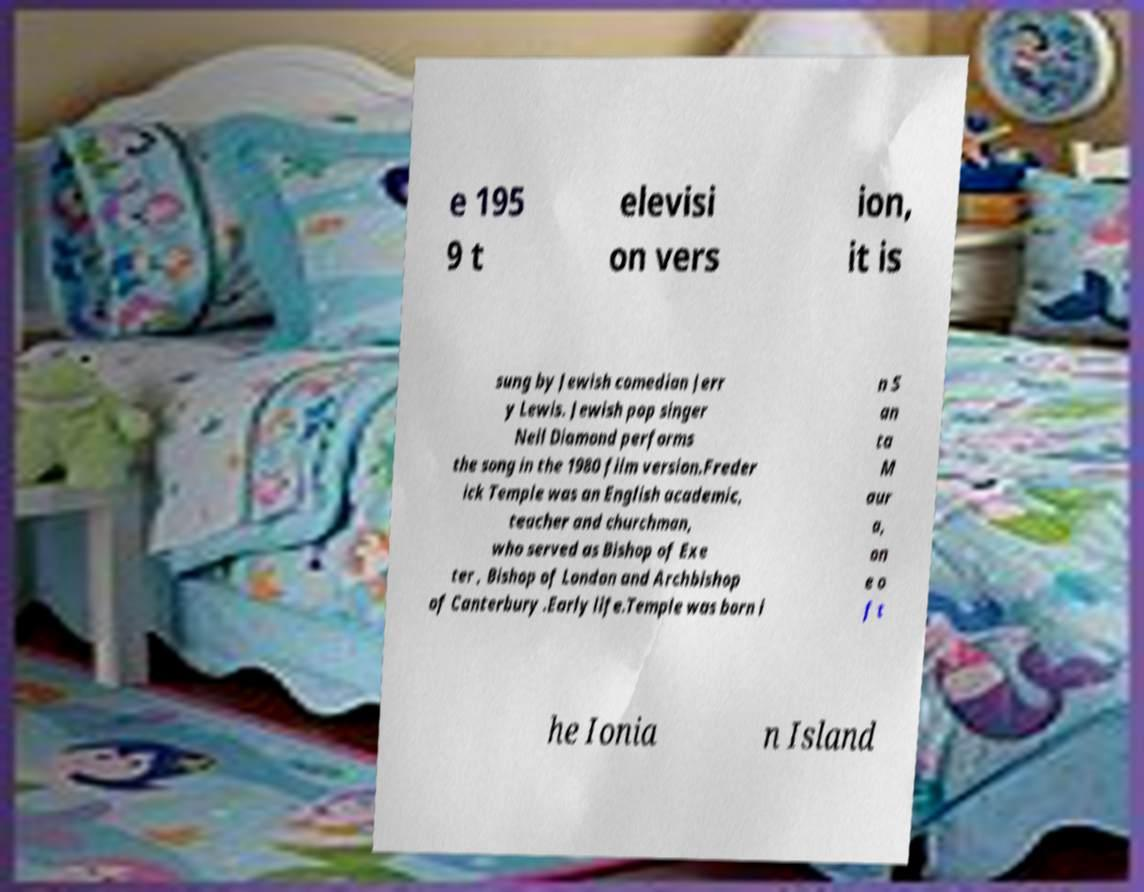There's text embedded in this image that I need extracted. Can you transcribe it verbatim? e 195 9 t elevisi on vers ion, it is sung by Jewish comedian Jerr y Lewis. Jewish pop singer Neil Diamond performs the song in the 1980 film version.Freder ick Temple was an English academic, teacher and churchman, who served as Bishop of Exe ter , Bishop of London and Archbishop of Canterbury .Early life.Temple was born i n S an ta M aur a, on e o f t he Ionia n Island 